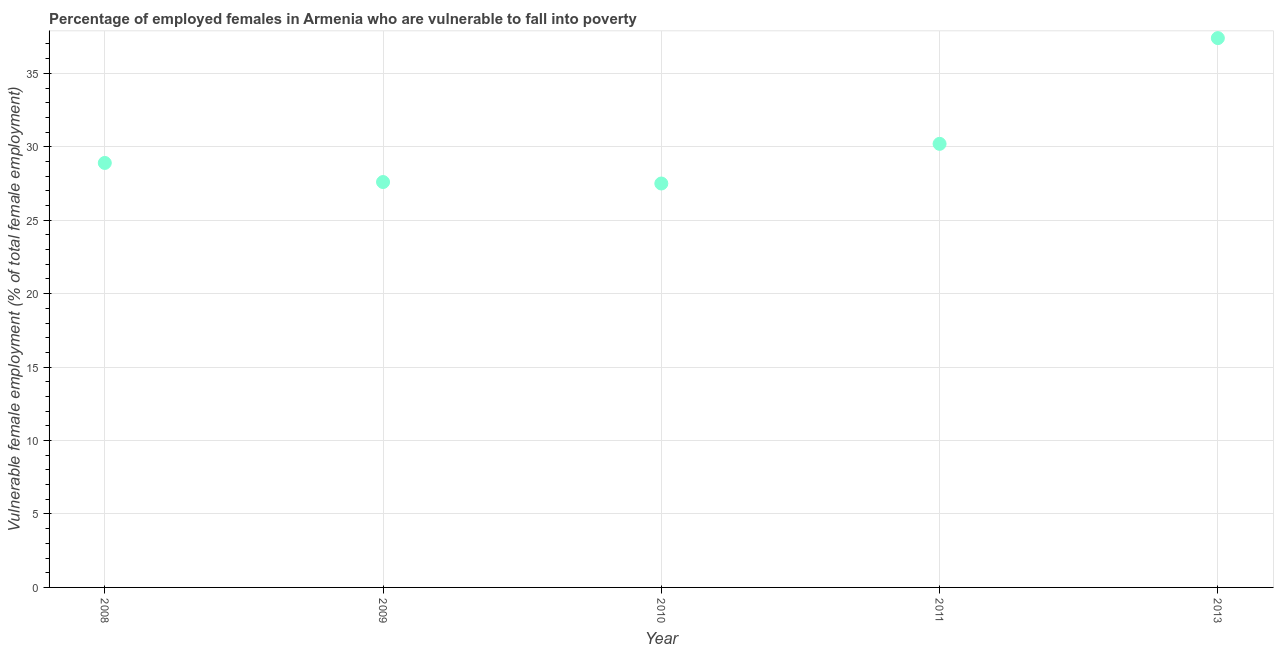What is the percentage of employed females who are vulnerable to fall into poverty in 2009?
Your response must be concise. 27.6. Across all years, what is the maximum percentage of employed females who are vulnerable to fall into poverty?
Offer a terse response. 37.4. Across all years, what is the minimum percentage of employed females who are vulnerable to fall into poverty?
Your response must be concise. 27.5. In which year was the percentage of employed females who are vulnerable to fall into poverty minimum?
Keep it short and to the point. 2010. What is the sum of the percentage of employed females who are vulnerable to fall into poverty?
Keep it short and to the point. 151.6. What is the difference between the percentage of employed females who are vulnerable to fall into poverty in 2010 and 2013?
Make the answer very short. -9.9. What is the average percentage of employed females who are vulnerable to fall into poverty per year?
Provide a short and direct response. 30.32. What is the median percentage of employed females who are vulnerable to fall into poverty?
Offer a terse response. 28.9. In how many years, is the percentage of employed females who are vulnerable to fall into poverty greater than 7 %?
Make the answer very short. 5. Do a majority of the years between 2011 and 2013 (inclusive) have percentage of employed females who are vulnerable to fall into poverty greater than 11 %?
Offer a very short reply. Yes. What is the ratio of the percentage of employed females who are vulnerable to fall into poverty in 2010 to that in 2013?
Provide a succinct answer. 0.74. Is the percentage of employed females who are vulnerable to fall into poverty in 2010 less than that in 2011?
Provide a succinct answer. Yes. Is the difference between the percentage of employed females who are vulnerable to fall into poverty in 2010 and 2011 greater than the difference between any two years?
Give a very brief answer. No. What is the difference between the highest and the second highest percentage of employed females who are vulnerable to fall into poverty?
Make the answer very short. 7.2. Is the sum of the percentage of employed females who are vulnerable to fall into poverty in 2008 and 2010 greater than the maximum percentage of employed females who are vulnerable to fall into poverty across all years?
Your response must be concise. Yes. What is the difference between the highest and the lowest percentage of employed females who are vulnerable to fall into poverty?
Give a very brief answer. 9.9. How many dotlines are there?
Your response must be concise. 1. How many years are there in the graph?
Keep it short and to the point. 5. Does the graph contain any zero values?
Provide a short and direct response. No. Does the graph contain grids?
Offer a very short reply. Yes. What is the title of the graph?
Ensure brevity in your answer.  Percentage of employed females in Armenia who are vulnerable to fall into poverty. What is the label or title of the X-axis?
Provide a succinct answer. Year. What is the label or title of the Y-axis?
Your response must be concise. Vulnerable female employment (% of total female employment). What is the Vulnerable female employment (% of total female employment) in 2008?
Offer a terse response. 28.9. What is the Vulnerable female employment (% of total female employment) in 2009?
Your answer should be compact. 27.6. What is the Vulnerable female employment (% of total female employment) in 2011?
Make the answer very short. 30.2. What is the Vulnerable female employment (% of total female employment) in 2013?
Keep it short and to the point. 37.4. What is the difference between the Vulnerable female employment (% of total female employment) in 2008 and 2010?
Keep it short and to the point. 1.4. What is the difference between the Vulnerable female employment (% of total female employment) in 2008 and 2013?
Your answer should be compact. -8.5. What is the difference between the Vulnerable female employment (% of total female employment) in 2009 and 2010?
Provide a succinct answer. 0.1. What is the difference between the Vulnerable female employment (% of total female employment) in 2009 and 2011?
Your response must be concise. -2.6. What is the difference between the Vulnerable female employment (% of total female employment) in 2009 and 2013?
Provide a succinct answer. -9.8. What is the difference between the Vulnerable female employment (% of total female employment) in 2010 and 2013?
Your answer should be compact. -9.9. What is the difference between the Vulnerable female employment (% of total female employment) in 2011 and 2013?
Give a very brief answer. -7.2. What is the ratio of the Vulnerable female employment (% of total female employment) in 2008 to that in 2009?
Give a very brief answer. 1.05. What is the ratio of the Vulnerable female employment (% of total female employment) in 2008 to that in 2010?
Keep it short and to the point. 1.05. What is the ratio of the Vulnerable female employment (% of total female employment) in 2008 to that in 2011?
Make the answer very short. 0.96. What is the ratio of the Vulnerable female employment (% of total female employment) in 2008 to that in 2013?
Your answer should be very brief. 0.77. What is the ratio of the Vulnerable female employment (% of total female employment) in 2009 to that in 2010?
Provide a succinct answer. 1. What is the ratio of the Vulnerable female employment (% of total female employment) in 2009 to that in 2011?
Provide a succinct answer. 0.91. What is the ratio of the Vulnerable female employment (% of total female employment) in 2009 to that in 2013?
Offer a very short reply. 0.74. What is the ratio of the Vulnerable female employment (% of total female employment) in 2010 to that in 2011?
Provide a short and direct response. 0.91. What is the ratio of the Vulnerable female employment (% of total female employment) in 2010 to that in 2013?
Offer a terse response. 0.73. What is the ratio of the Vulnerable female employment (% of total female employment) in 2011 to that in 2013?
Offer a terse response. 0.81. 